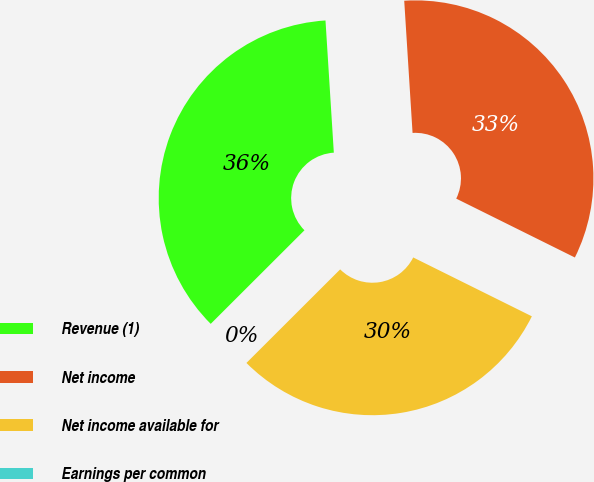<chart> <loc_0><loc_0><loc_500><loc_500><pie_chart><fcel>Revenue (1)<fcel>Net income<fcel>Net income available for<fcel>Earnings per common<nl><fcel>36.48%<fcel>33.33%<fcel>30.18%<fcel>0.0%<nl></chart> 